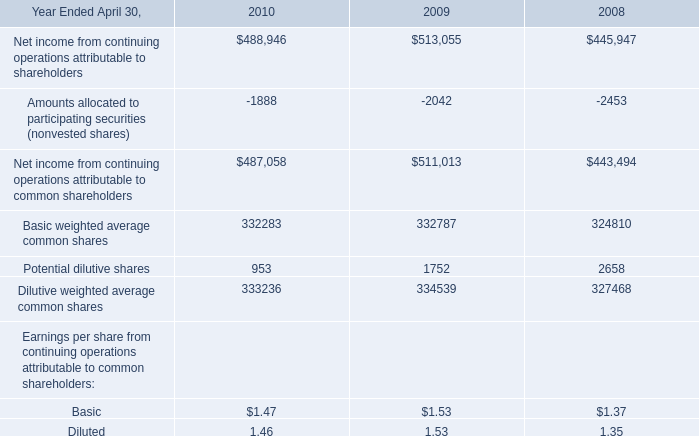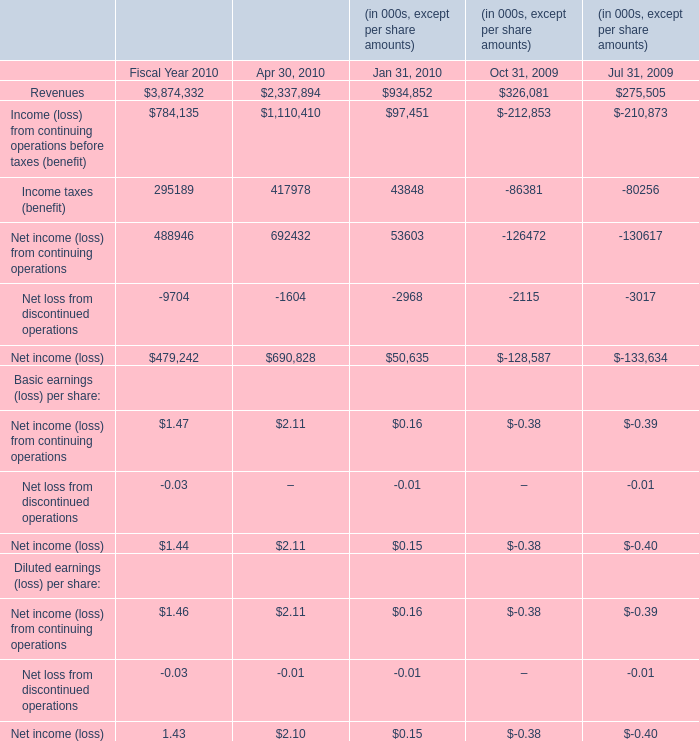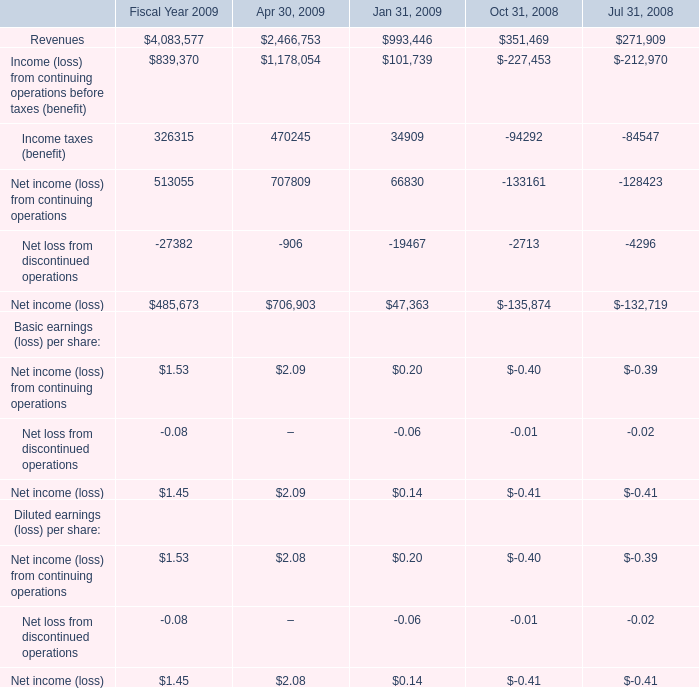What is the Revenues for Fiscal Year 2009 ? 
Answer: 4083577. 